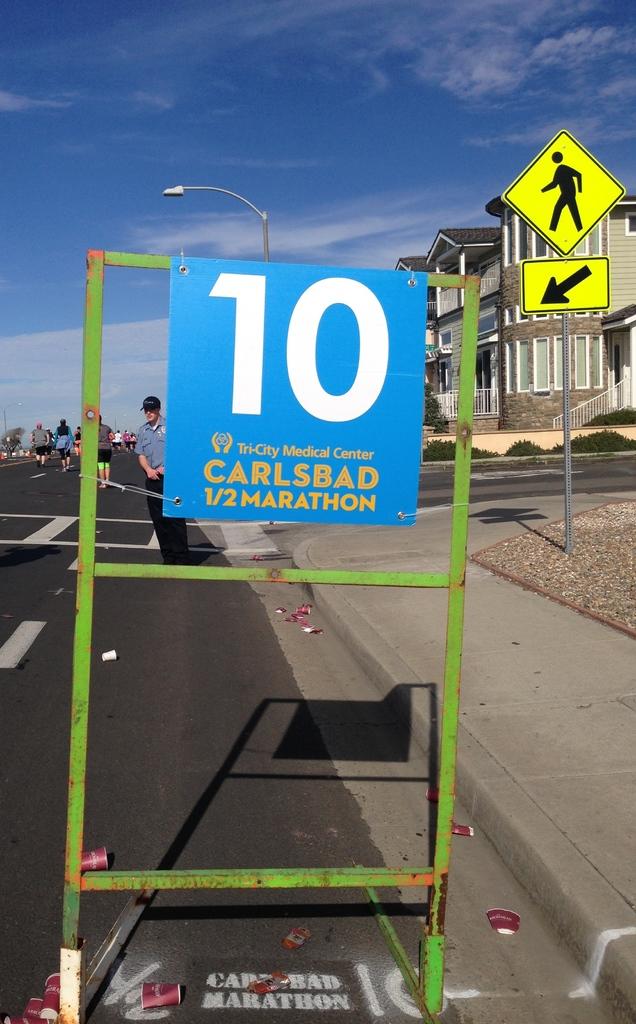Is there a marathon?
Your response must be concise. Yes. Where is this?
Your response must be concise. Carlsbad. 